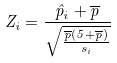<formula> <loc_0><loc_0><loc_500><loc_500>Z _ { i } = \frac { \hat { p } _ { i } + \overline { p } } { \sqrt { \frac { \overline { p } ( 5 + \overline { p } ) } { s _ { i } } } }</formula> 